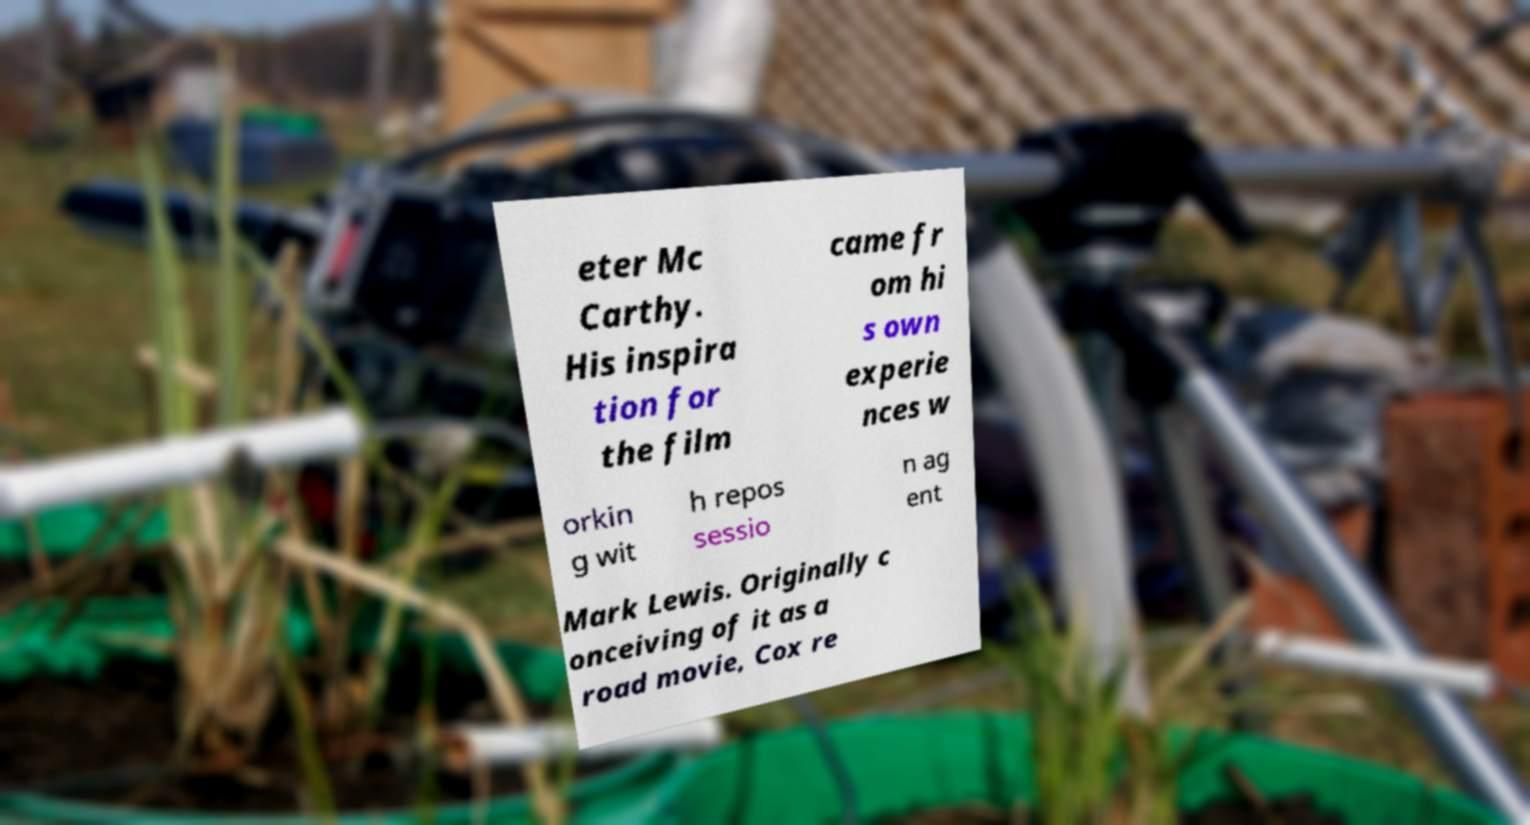What messages or text are displayed in this image? I need them in a readable, typed format. eter Mc Carthy. His inspira tion for the film came fr om hi s own experie nces w orkin g wit h repos sessio n ag ent Mark Lewis. Originally c onceiving of it as a road movie, Cox re 